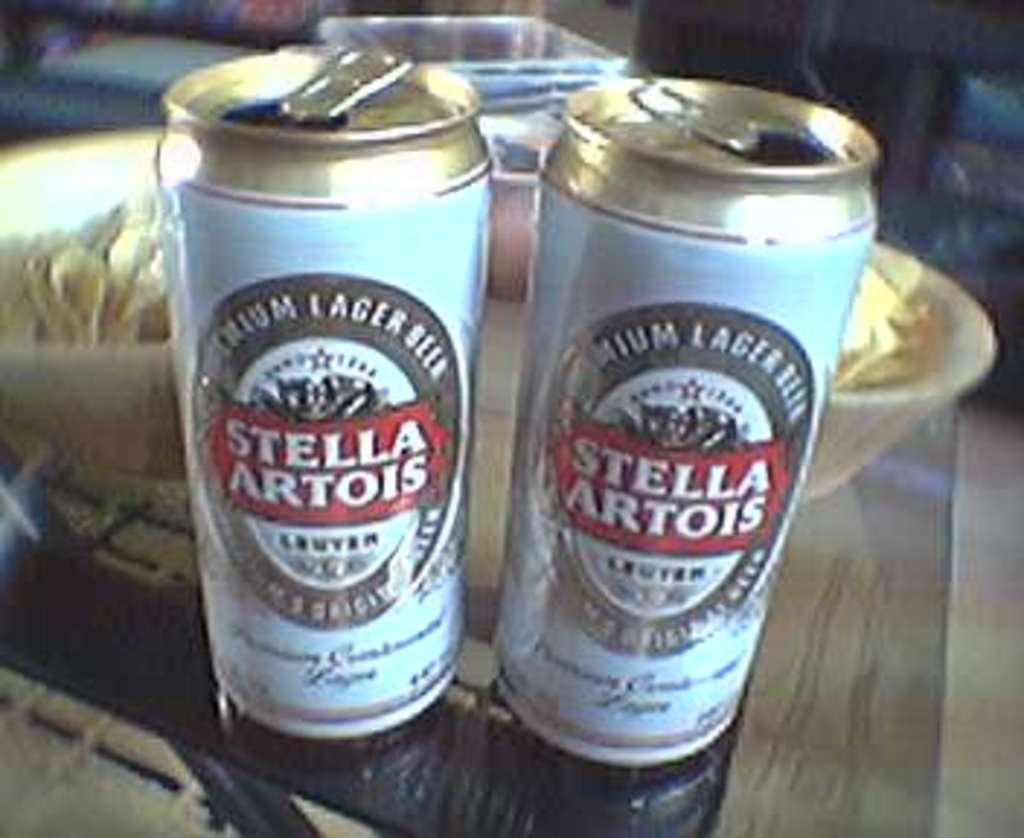<image>
Give a short and clear explanation of the subsequent image. A pair of tall boy cans of Stella Artois lager/ 